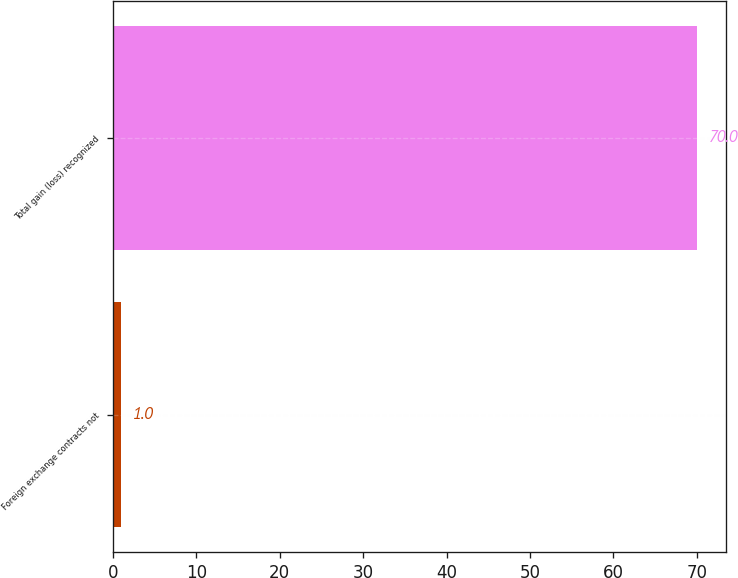<chart> <loc_0><loc_0><loc_500><loc_500><bar_chart><fcel>Foreign exchange contracts not<fcel>Total gain (loss) recognized<nl><fcel>1<fcel>70<nl></chart> 